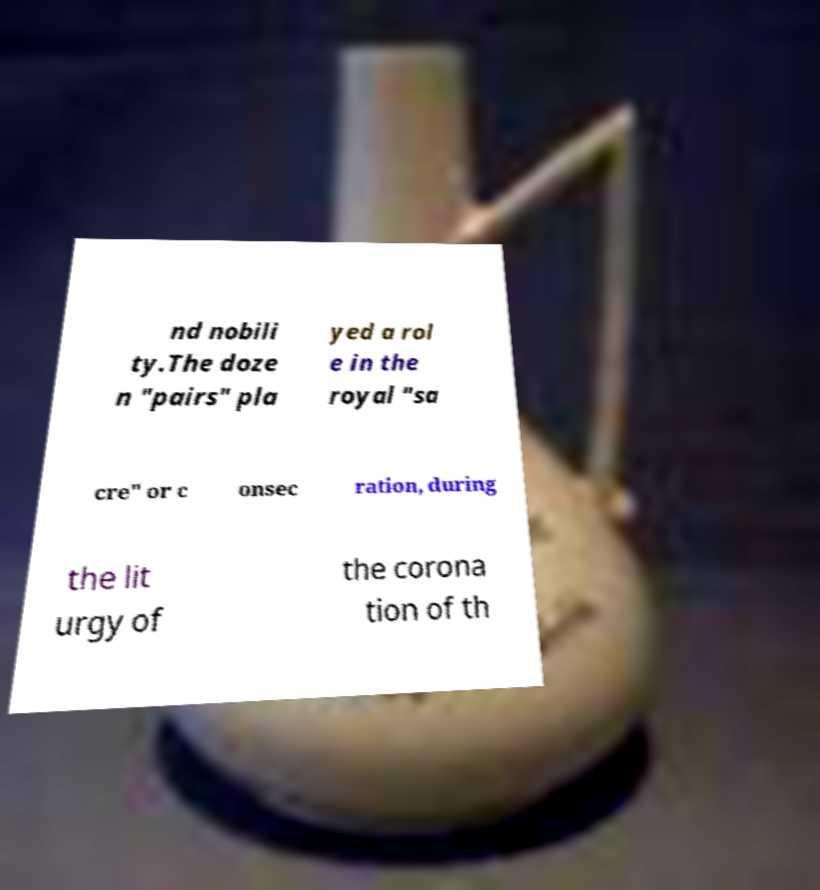For documentation purposes, I need the text within this image transcribed. Could you provide that? nd nobili ty.The doze n "pairs" pla yed a rol e in the royal "sa cre" or c onsec ration, during the lit urgy of the corona tion of th 